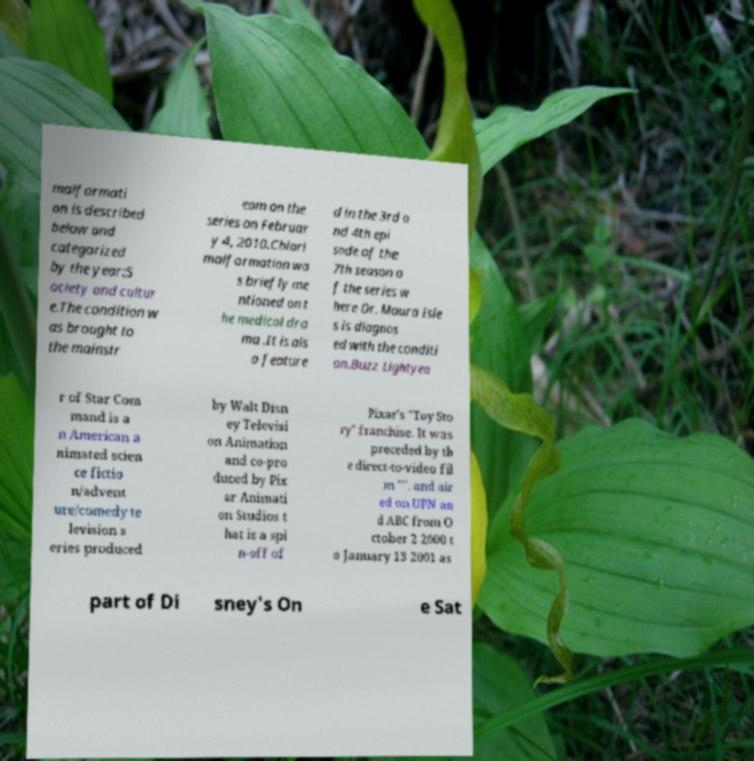Can you read and provide the text displayed in the image?This photo seems to have some interesting text. Can you extract and type it out for me? malformati on is described below and categorized by the year:S ociety and cultur e.The condition w as brought to the mainstr eam on the series on Februar y 4, 2010.Chiari malformation wa s briefly me ntioned on t he medical dra ma .It is als o feature d in the 3rd a nd 4th epi sode of the 7th season o f the series w here Dr. Maura Isle s is diagnos ed with the conditi on.Buzz Lightyea r of Star Com mand is a n American a nimated scien ce fictio n/advent ure/comedy te levision s eries produced by Walt Disn ey Televisi on Animation and co-pro duced by Pix ar Animati on Studios t hat is a spi n-off of Pixar's "Toy Sto ry" franchise. It was preceded by th e direct-to-video fil m "". and air ed on UPN an d ABC from O ctober 2 2000 t o January 13 2001 as part of Di sney's On e Sat 